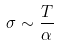<formula> <loc_0><loc_0><loc_500><loc_500>\sigma \sim \frac { T } { \alpha }</formula> 